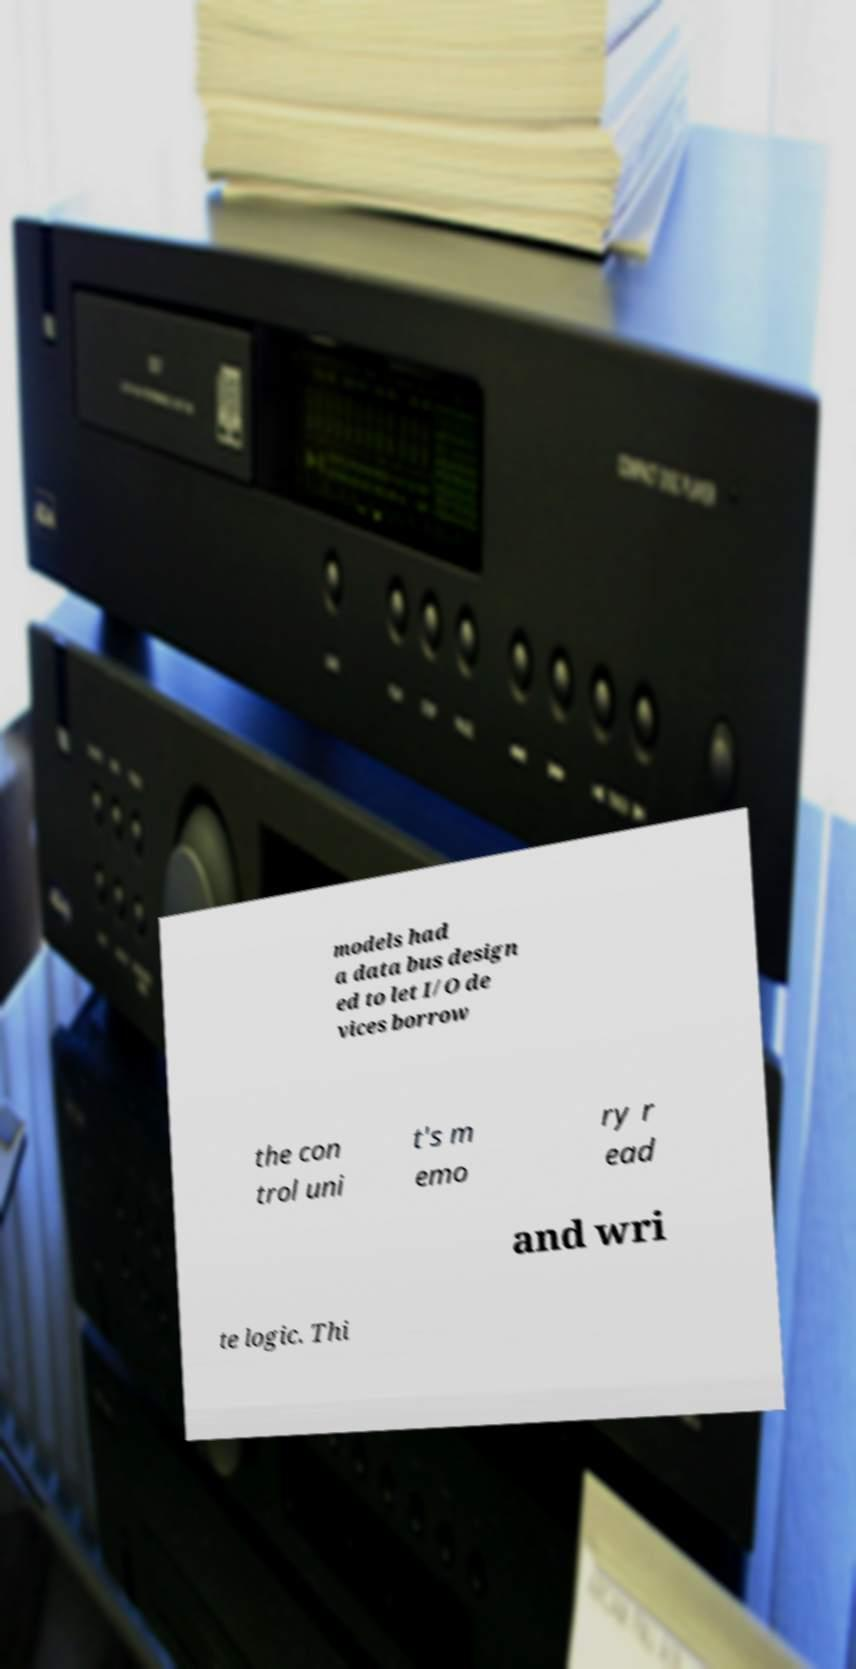Please read and relay the text visible in this image. What does it say? models had a data bus design ed to let I/O de vices borrow the con trol uni t's m emo ry r ead and wri te logic. Thi 